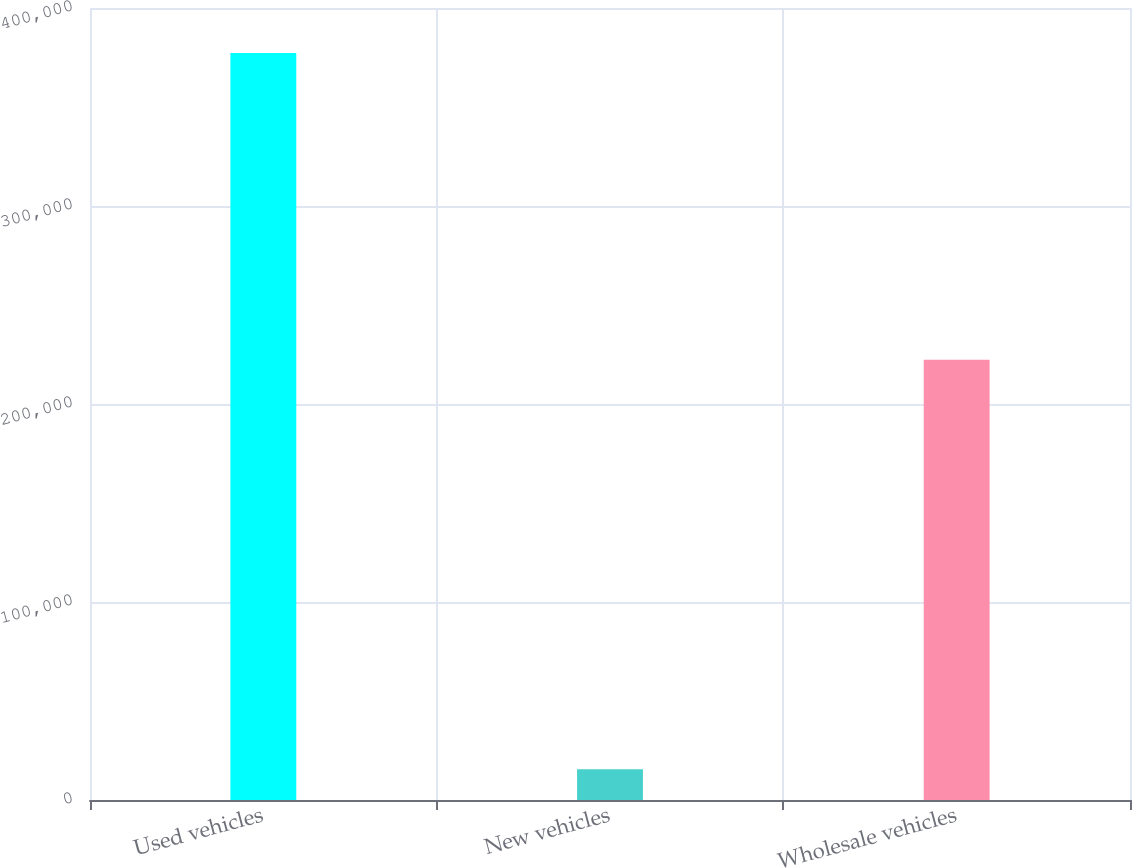<chart> <loc_0><loc_0><loc_500><loc_500><bar_chart><fcel>Used vehicles<fcel>New vehicles<fcel>Wholesale vehicles<nl><fcel>377244<fcel>15485<fcel>222406<nl></chart> 